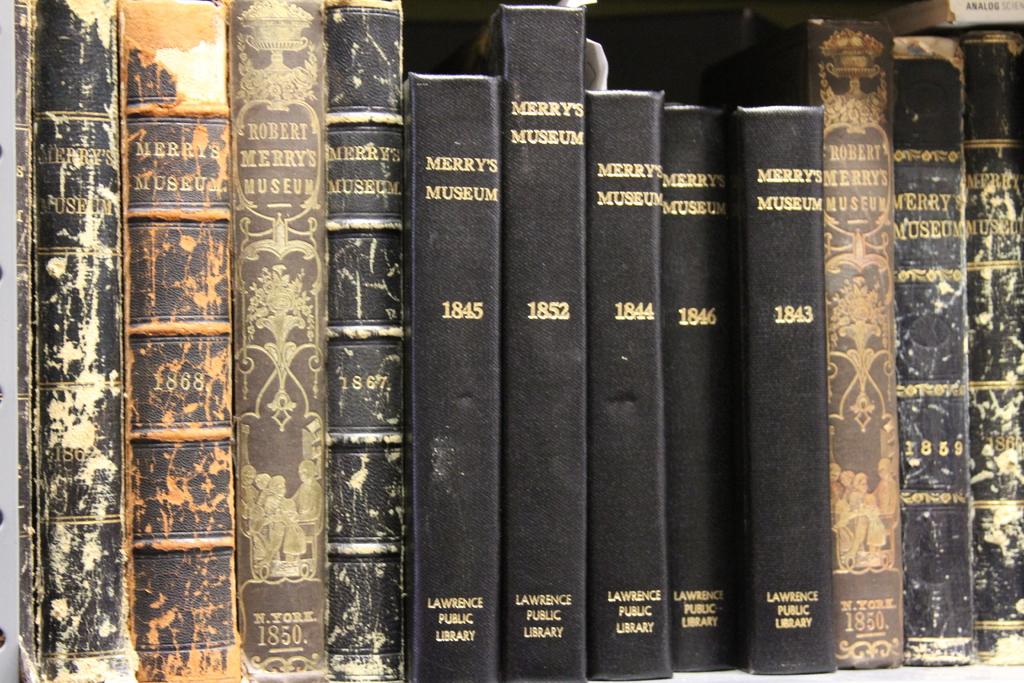What library are these tomes from?
Your answer should be very brief. Lawrence public library. What century is this from?
Provide a succinct answer. 19th. 